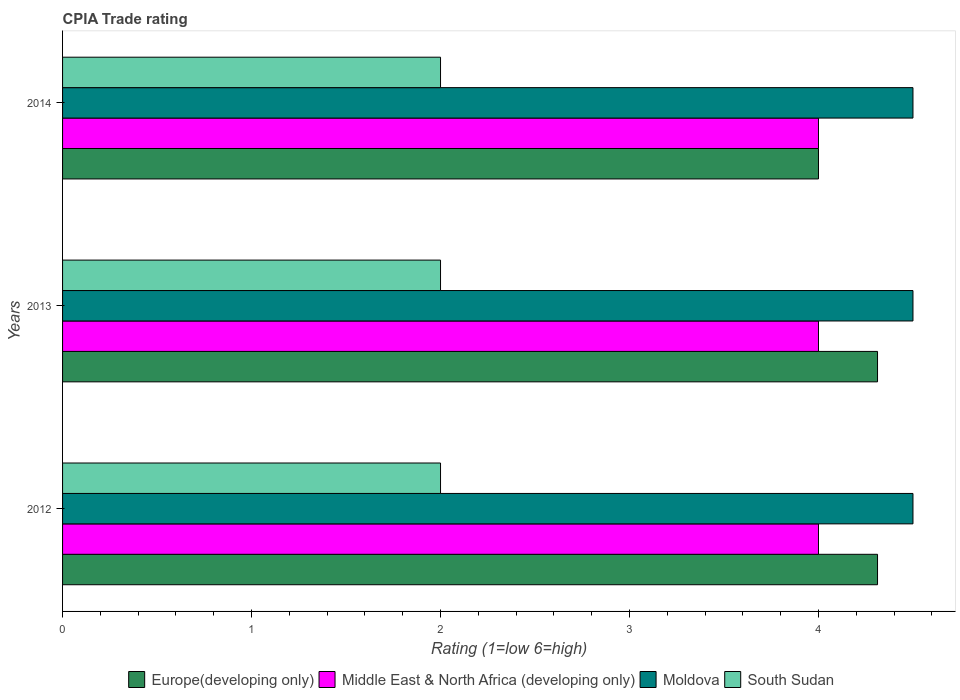How many bars are there on the 2nd tick from the top?
Offer a very short reply. 4. How many bars are there on the 3rd tick from the bottom?
Offer a very short reply. 4. What is the label of the 1st group of bars from the top?
Make the answer very short. 2014. What is the CPIA rating in South Sudan in 2014?
Make the answer very short. 2. Across all years, what is the maximum CPIA rating in Europe(developing only)?
Keep it short and to the point. 4.31. Across all years, what is the minimum CPIA rating in Europe(developing only)?
Ensure brevity in your answer.  4. What is the total CPIA rating in Europe(developing only) in the graph?
Offer a terse response. 12.62. What is the difference between the CPIA rating in Europe(developing only) in 2012 and that in 2014?
Offer a terse response. 0.31. What is the difference between the CPIA rating in Moldova in 2014 and the CPIA rating in Middle East & North Africa (developing only) in 2012?
Your answer should be very brief. 0.5. What is the average CPIA rating in Europe(developing only) per year?
Offer a very short reply. 4.21. In the year 2013, what is the difference between the CPIA rating in Europe(developing only) and CPIA rating in South Sudan?
Give a very brief answer. 2.31. Is the difference between the CPIA rating in Europe(developing only) in 2012 and 2014 greater than the difference between the CPIA rating in South Sudan in 2012 and 2014?
Provide a succinct answer. Yes. What is the difference between the highest and the lowest CPIA rating in South Sudan?
Provide a succinct answer. 0. What does the 4th bar from the top in 2014 represents?
Your answer should be very brief. Europe(developing only). What does the 1st bar from the bottom in 2014 represents?
Provide a succinct answer. Europe(developing only). What is the difference between two consecutive major ticks on the X-axis?
Provide a succinct answer. 1. Are the values on the major ticks of X-axis written in scientific E-notation?
Make the answer very short. No. Does the graph contain grids?
Your response must be concise. No. Where does the legend appear in the graph?
Offer a very short reply. Bottom center. How are the legend labels stacked?
Your answer should be very brief. Horizontal. What is the title of the graph?
Provide a short and direct response. CPIA Trade rating. What is the label or title of the X-axis?
Your response must be concise. Rating (1=low 6=high). What is the Rating (1=low 6=high) of Europe(developing only) in 2012?
Your response must be concise. 4.31. What is the Rating (1=low 6=high) of Moldova in 2012?
Give a very brief answer. 4.5. What is the Rating (1=low 6=high) of South Sudan in 2012?
Offer a terse response. 2. What is the Rating (1=low 6=high) of Europe(developing only) in 2013?
Provide a succinct answer. 4.31. What is the Rating (1=low 6=high) in Middle East & North Africa (developing only) in 2013?
Provide a succinct answer. 4. What is the Rating (1=low 6=high) of Moldova in 2013?
Offer a very short reply. 4.5. What is the Rating (1=low 6=high) in Europe(developing only) in 2014?
Ensure brevity in your answer.  4. What is the Rating (1=low 6=high) in Moldova in 2014?
Make the answer very short. 4.5. What is the Rating (1=low 6=high) of South Sudan in 2014?
Provide a succinct answer. 2. Across all years, what is the maximum Rating (1=low 6=high) in Europe(developing only)?
Your answer should be compact. 4.31. Across all years, what is the maximum Rating (1=low 6=high) in Middle East & North Africa (developing only)?
Make the answer very short. 4. Across all years, what is the minimum Rating (1=low 6=high) of Middle East & North Africa (developing only)?
Your answer should be very brief. 4. What is the total Rating (1=low 6=high) of Europe(developing only) in the graph?
Your response must be concise. 12.62. What is the total Rating (1=low 6=high) in Middle East & North Africa (developing only) in the graph?
Your response must be concise. 12. What is the difference between the Rating (1=low 6=high) in Middle East & North Africa (developing only) in 2012 and that in 2013?
Keep it short and to the point. 0. What is the difference between the Rating (1=low 6=high) in Europe(developing only) in 2012 and that in 2014?
Give a very brief answer. 0.31. What is the difference between the Rating (1=low 6=high) of Moldova in 2012 and that in 2014?
Make the answer very short. 0. What is the difference between the Rating (1=low 6=high) in Europe(developing only) in 2013 and that in 2014?
Make the answer very short. 0.31. What is the difference between the Rating (1=low 6=high) in Middle East & North Africa (developing only) in 2013 and that in 2014?
Your answer should be compact. 0. What is the difference between the Rating (1=low 6=high) of Moldova in 2013 and that in 2014?
Your answer should be very brief. 0. What is the difference between the Rating (1=low 6=high) of South Sudan in 2013 and that in 2014?
Provide a succinct answer. 0. What is the difference between the Rating (1=low 6=high) in Europe(developing only) in 2012 and the Rating (1=low 6=high) in Middle East & North Africa (developing only) in 2013?
Provide a succinct answer. 0.31. What is the difference between the Rating (1=low 6=high) of Europe(developing only) in 2012 and the Rating (1=low 6=high) of Moldova in 2013?
Keep it short and to the point. -0.19. What is the difference between the Rating (1=low 6=high) in Europe(developing only) in 2012 and the Rating (1=low 6=high) in South Sudan in 2013?
Your response must be concise. 2.31. What is the difference between the Rating (1=low 6=high) in Middle East & North Africa (developing only) in 2012 and the Rating (1=low 6=high) in Moldova in 2013?
Your answer should be very brief. -0.5. What is the difference between the Rating (1=low 6=high) of Moldova in 2012 and the Rating (1=low 6=high) of South Sudan in 2013?
Provide a short and direct response. 2.5. What is the difference between the Rating (1=low 6=high) of Europe(developing only) in 2012 and the Rating (1=low 6=high) of Middle East & North Africa (developing only) in 2014?
Keep it short and to the point. 0.31. What is the difference between the Rating (1=low 6=high) of Europe(developing only) in 2012 and the Rating (1=low 6=high) of Moldova in 2014?
Your answer should be very brief. -0.19. What is the difference between the Rating (1=low 6=high) in Europe(developing only) in 2012 and the Rating (1=low 6=high) in South Sudan in 2014?
Give a very brief answer. 2.31. What is the difference between the Rating (1=low 6=high) of Moldova in 2012 and the Rating (1=low 6=high) of South Sudan in 2014?
Provide a short and direct response. 2.5. What is the difference between the Rating (1=low 6=high) of Europe(developing only) in 2013 and the Rating (1=low 6=high) of Middle East & North Africa (developing only) in 2014?
Your response must be concise. 0.31. What is the difference between the Rating (1=low 6=high) of Europe(developing only) in 2013 and the Rating (1=low 6=high) of Moldova in 2014?
Provide a succinct answer. -0.19. What is the difference between the Rating (1=low 6=high) of Europe(developing only) in 2013 and the Rating (1=low 6=high) of South Sudan in 2014?
Your answer should be very brief. 2.31. What is the difference between the Rating (1=low 6=high) in Middle East & North Africa (developing only) in 2013 and the Rating (1=low 6=high) in Moldova in 2014?
Offer a terse response. -0.5. What is the average Rating (1=low 6=high) of Europe(developing only) per year?
Give a very brief answer. 4.21. What is the average Rating (1=low 6=high) of Middle East & North Africa (developing only) per year?
Your answer should be very brief. 4. What is the average Rating (1=low 6=high) in Moldova per year?
Keep it short and to the point. 4.5. In the year 2012, what is the difference between the Rating (1=low 6=high) in Europe(developing only) and Rating (1=low 6=high) in Middle East & North Africa (developing only)?
Provide a short and direct response. 0.31. In the year 2012, what is the difference between the Rating (1=low 6=high) of Europe(developing only) and Rating (1=low 6=high) of Moldova?
Your response must be concise. -0.19. In the year 2012, what is the difference between the Rating (1=low 6=high) of Europe(developing only) and Rating (1=low 6=high) of South Sudan?
Make the answer very short. 2.31. In the year 2012, what is the difference between the Rating (1=low 6=high) of Middle East & North Africa (developing only) and Rating (1=low 6=high) of South Sudan?
Ensure brevity in your answer.  2. In the year 2012, what is the difference between the Rating (1=low 6=high) of Moldova and Rating (1=low 6=high) of South Sudan?
Provide a short and direct response. 2.5. In the year 2013, what is the difference between the Rating (1=low 6=high) in Europe(developing only) and Rating (1=low 6=high) in Middle East & North Africa (developing only)?
Offer a terse response. 0.31. In the year 2013, what is the difference between the Rating (1=low 6=high) in Europe(developing only) and Rating (1=low 6=high) in Moldova?
Your answer should be very brief. -0.19. In the year 2013, what is the difference between the Rating (1=low 6=high) of Europe(developing only) and Rating (1=low 6=high) of South Sudan?
Offer a very short reply. 2.31. In the year 2013, what is the difference between the Rating (1=low 6=high) in Middle East & North Africa (developing only) and Rating (1=low 6=high) in South Sudan?
Provide a succinct answer. 2. In the year 2014, what is the difference between the Rating (1=low 6=high) of Middle East & North Africa (developing only) and Rating (1=low 6=high) of Moldova?
Provide a succinct answer. -0.5. In the year 2014, what is the difference between the Rating (1=low 6=high) in Moldova and Rating (1=low 6=high) in South Sudan?
Provide a short and direct response. 2.5. What is the ratio of the Rating (1=low 6=high) in Europe(developing only) in 2012 to that in 2013?
Give a very brief answer. 1. What is the ratio of the Rating (1=low 6=high) of Middle East & North Africa (developing only) in 2012 to that in 2013?
Your response must be concise. 1. What is the ratio of the Rating (1=low 6=high) of Moldova in 2012 to that in 2013?
Offer a very short reply. 1. What is the ratio of the Rating (1=low 6=high) in South Sudan in 2012 to that in 2013?
Keep it short and to the point. 1. What is the ratio of the Rating (1=low 6=high) in Europe(developing only) in 2012 to that in 2014?
Keep it short and to the point. 1.08. What is the ratio of the Rating (1=low 6=high) of Moldova in 2012 to that in 2014?
Your answer should be very brief. 1. What is the ratio of the Rating (1=low 6=high) of South Sudan in 2012 to that in 2014?
Offer a very short reply. 1. What is the ratio of the Rating (1=low 6=high) in Europe(developing only) in 2013 to that in 2014?
Your answer should be compact. 1.08. What is the ratio of the Rating (1=low 6=high) of Middle East & North Africa (developing only) in 2013 to that in 2014?
Provide a succinct answer. 1. What is the ratio of the Rating (1=low 6=high) in Moldova in 2013 to that in 2014?
Give a very brief answer. 1. What is the ratio of the Rating (1=low 6=high) in South Sudan in 2013 to that in 2014?
Offer a very short reply. 1. What is the difference between the highest and the second highest Rating (1=low 6=high) of Europe(developing only)?
Provide a short and direct response. 0. What is the difference between the highest and the second highest Rating (1=low 6=high) of South Sudan?
Your response must be concise. 0. What is the difference between the highest and the lowest Rating (1=low 6=high) of Europe(developing only)?
Give a very brief answer. 0.31. 